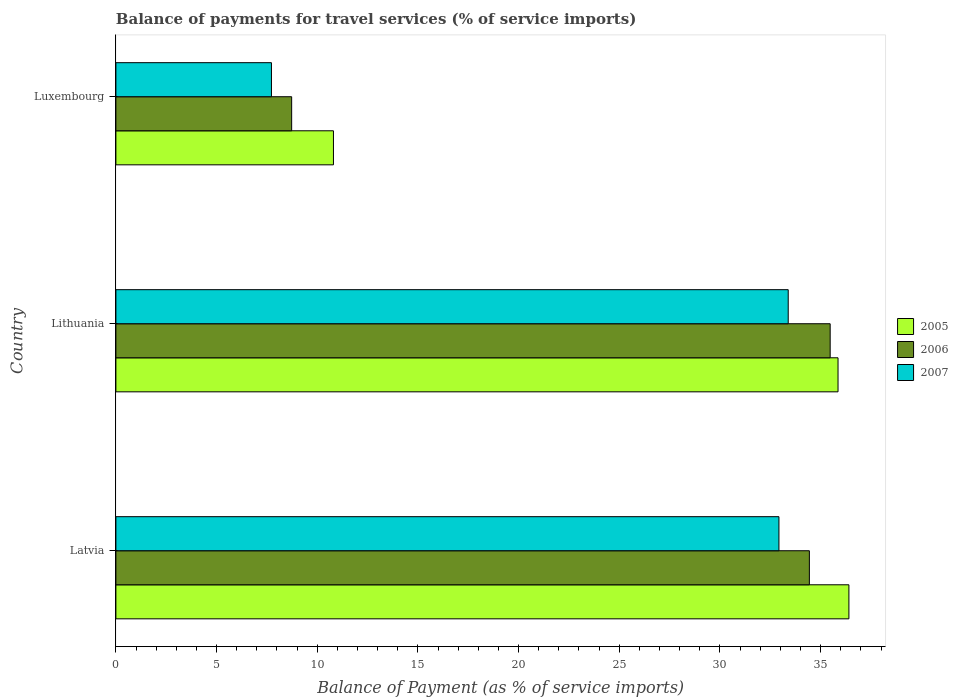Are the number of bars per tick equal to the number of legend labels?
Provide a short and direct response. Yes. Are the number of bars on each tick of the Y-axis equal?
Provide a succinct answer. Yes. How many bars are there on the 2nd tick from the bottom?
Ensure brevity in your answer.  3. What is the label of the 3rd group of bars from the top?
Provide a short and direct response. Latvia. What is the balance of payments for travel services in 2007 in Luxembourg?
Your answer should be very brief. 7.73. Across all countries, what is the maximum balance of payments for travel services in 2006?
Offer a terse response. 35.48. Across all countries, what is the minimum balance of payments for travel services in 2007?
Your answer should be compact. 7.73. In which country was the balance of payments for travel services in 2007 maximum?
Offer a terse response. Lithuania. In which country was the balance of payments for travel services in 2006 minimum?
Give a very brief answer. Luxembourg. What is the total balance of payments for travel services in 2006 in the graph?
Ensure brevity in your answer.  78.65. What is the difference between the balance of payments for travel services in 2006 in Latvia and that in Luxembourg?
Your answer should be compact. 25.71. What is the difference between the balance of payments for travel services in 2007 in Lithuania and the balance of payments for travel services in 2006 in Latvia?
Your answer should be very brief. -1.05. What is the average balance of payments for travel services in 2005 per country?
Your answer should be very brief. 27.69. What is the difference between the balance of payments for travel services in 2006 and balance of payments for travel services in 2007 in Luxembourg?
Keep it short and to the point. 1. What is the ratio of the balance of payments for travel services in 2007 in Latvia to that in Luxembourg?
Your answer should be very brief. 4.26. Is the difference between the balance of payments for travel services in 2006 in Lithuania and Luxembourg greater than the difference between the balance of payments for travel services in 2007 in Lithuania and Luxembourg?
Make the answer very short. Yes. What is the difference between the highest and the second highest balance of payments for travel services in 2007?
Your answer should be compact. 0.46. What is the difference between the highest and the lowest balance of payments for travel services in 2007?
Keep it short and to the point. 25.67. In how many countries, is the balance of payments for travel services in 2005 greater than the average balance of payments for travel services in 2005 taken over all countries?
Give a very brief answer. 2. Is the sum of the balance of payments for travel services in 2007 in Latvia and Lithuania greater than the maximum balance of payments for travel services in 2006 across all countries?
Offer a terse response. Yes. What does the 1st bar from the bottom in Luxembourg represents?
Offer a very short reply. 2005. Is it the case that in every country, the sum of the balance of payments for travel services in 2006 and balance of payments for travel services in 2007 is greater than the balance of payments for travel services in 2005?
Ensure brevity in your answer.  Yes. How many bars are there?
Offer a terse response. 9. Are the values on the major ticks of X-axis written in scientific E-notation?
Make the answer very short. No. Does the graph contain any zero values?
Provide a succinct answer. No. Where does the legend appear in the graph?
Ensure brevity in your answer.  Center right. How many legend labels are there?
Offer a terse response. 3. What is the title of the graph?
Your answer should be very brief. Balance of payments for travel services (% of service imports). What is the label or title of the X-axis?
Keep it short and to the point. Balance of Payment (as % of service imports). What is the Balance of Payment (as % of service imports) of 2005 in Latvia?
Make the answer very short. 36.41. What is the Balance of Payment (as % of service imports) in 2006 in Latvia?
Provide a short and direct response. 34.44. What is the Balance of Payment (as % of service imports) of 2007 in Latvia?
Provide a short and direct response. 32.93. What is the Balance of Payment (as % of service imports) of 2005 in Lithuania?
Ensure brevity in your answer.  35.87. What is the Balance of Payment (as % of service imports) in 2006 in Lithuania?
Give a very brief answer. 35.48. What is the Balance of Payment (as % of service imports) in 2007 in Lithuania?
Your response must be concise. 33.39. What is the Balance of Payment (as % of service imports) in 2005 in Luxembourg?
Your response must be concise. 10.81. What is the Balance of Payment (as % of service imports) in 2006 in Luxembourg?
Your answer should be compact. 8.73. What is the Balance of Payment (as % of service imports) of 2007 in Luxembourg?
Your answer should be compact. 7.73. Across all countries, what is the maximum Balance of Payment (as % of service imports) of 2005?
Provide a succinct answer. 36.41. Across all countries, what is the maximum Balance of Payment (as % of service imports) in 2006?
Offer a terse response. 35.48. Across all countries, what is the maximum Balance of Payment (as % of service imports) of 2007?
Offer a very short reply. 33.39. Across all countries, what is the minimum Balance of Payment (as % of service imports) in 2005?
Provide a succinct answer. 10.81. Across all countries, what is the minimum Balance of Payment (as % of service imports) in 2006?
Provide a short and direct response. 8.73. Across all countries, what is the minimum Balance of Payment (as % of service imports) in 2007?
Provide a succinct answer. 7.73. What is the total Balance of Payment (as % of service imports) of 2005 in the graph?
Ensure brevity in your answer.  83.08. What is the total Balance of Payment (as % of service imports) of 2006 in the graph?
Offer a very short reply. 78.65. What is the total Balance of Payment (as % of service imports) in 2007 in the graph?
Your response must be concise. 74.05. What is the difference between the Balance of Payment (as % of service imports) of 2005 in Latvia and that in Lithuania?
Your response must be concise. 0.54. What is the difference between the Balance of Payment (as % of service imports) of 2006 in Latvia and that in Lithuania?
Your response must be concise. -1.03. What is the difference between the Balance of Payment (as % of service imports) in 2007 in Latvia and that in Lithuania?
Your answer should be compact. -0.46. What is the difference between the Balance of Payment (as % of service imports) of 2005 in Latvia and that in Luxembourg?
Keep it short and to the point. 25.6. What is the difference between the Balance of Payment (as % of service imports) in 2006 in Latvia and that in Luxembourg?
Ensure brevity in your answer.  25.71. What is the difference between the Balance of Payment (as % of service imports) in 2007 in Latvia and that in Luxembourg?
Your answer should be compact. 25.21. What is the difference between the Balance of Payment (as % of service imports) of 2005 in Lithuania and that in Luxembourg?
Offer a terse response. 25.06. What is the difference between the Balance of Payment (as % of service imports) in 2006 in Lithuania and that in Luxembourg?
Your response must be concise. 26.75. What is the difference between the Balance of Payment (as % of service imports) of 2007 in Lithuania and that in Luxembourg?
Offer a terse response. 25.67. What is the difference between the Balance of Payment (as % of service imports) of 2005 in Latvia and the Balance of Payment (as % of service imports) of 2006 in Lithuania?
Your answer should be compact. 0.93. What is the difference between the Balance of Payment (as % of service imports) of 2005 in Latvia and the Balance of Payment (as % of service imports) of 2007 in Lithuania?
Ensure brevity in your answer.  3.01. What is the difference between the Balance of Payment (as % of service imports) in 2006 in Latvia and the Balance of Payment (as % of service imports) in 2007 in Lithuania?
Provide a short and direct response. 1.05. What is the difference between the Balance of Payment (as % of service imports) of 2005 in Latvia and the Balance of Payment (as % of service imports) of 2006 in Luxembourg?
Provide a short and direct response. 27.68. What is the difference between the Balance of Payment (as % of service imports) in 2005 in Latvia and the Balance of Payment (as % of service imports) in 2007 in Luxembourg?
Your response must be concise. 28.68. What is the difference between the Balance of Payment (as % of service imports) of 2006 in Latvia and the Balance of Payment (as % of service imports) of 2007 in Luxembourg?
Offer a very short reply. 26.72. What is the difference between the Balance of Payment (as % of service imports) of 2005 in Lithuania and the Balance of Payment (as % of service imports) of 2006 in Luxembourg?
Your response must be concise. 27.14. What is the difference between the Balance of Payment (as % of service imports) in 2005 in Lithuania and the Balance of Payment (as % of service imports) in 2007 in Luxembourg?
Your answer should be compact. 28.14. What is the difference between the Balance of Payment (as % of service imports) in 2006 in Lithuania and the Balance of Payment (as % of service imports) in 2007 in Luxembourg?
Your answer should be very brief. 27.75. What is the average Balance of Payment (as % of service imports) in 2005 per country?
Ensure brevity in your answer.  27.69. What is the average Balance of Payment (as % of service imports) of 2006 per country?
Offer a very short reply. 26.22. What is the average Balance of Payment (as % of service imports) of 2007 per country?
Make the answer very short. 24.68. What is the difference between the Balance of Payment (as % of service imports) in 2005 and Balance of Payment (as % of service imports) in 2006 in Latvia?
Give a very brief answer. 1.96. What is the difference between the Balance of Payment (as % of service imports) in 2005 and Balance of Payment (as % of service imports) in 2007 in Latvia?
Offer a very short reply. 3.47. What is the difference between the Balance of Payment (as % of service imports) of 2006 and Balance of Payment (as % of service imports) of 2007 in Latvia?
Provide a short and direct response. 1.51. What is the difference between the Balance of Payment (as % of service imports) of 2005 and Balance of Payment (as % of service imports) of 2006 in Lithuania?
Give a very brief answer. 0.39. What is the difference between the Balance of Payment (as % of service imports) in 2005 and Balance of Payment (as % of service imports) in 2007 in Lithuania?
Your answer should be compact. 2.47. What is the difference between the Balance of Payment (as % of service imports) in 2006 and Balance of Payment (as % of service imports) in 2007 in Lithuania?
Offer a very short reply. 2.08. What is the difference between the Balance of Payment (as % of service imports) of 2005 and Balance of Payment (as % of service imports) of 2006 in Luxembourg?
Your answer should be very brief. 2.08. What is the difference between the Balance of Payment (as % of service imports) of 2005 and Balance of Payment (as % of service imports) of 2007 in Luxembourg?
Your answer should be very brief. 3.08. What is the difference between the Balance of Payment (as % of service imports) in 2006 and Balance of Payment (as % of service imports) in 2007 in Luxembourg?
Offer a terse response. 1. What is the ratio of the Balance of Payment (as % of service imports) of 2005 in Latvia to that in Lithuania?
Offer a terse response. 1.01. What is the ratio of the Balance of Payment (as % of service imports) in 2006 in Latvia to that in Lithuania?
Ensure brevity in your answer.  0.97. What is the ratio of the Balance of Payment (as % of service imports) in 2007 in Latvia to that in Lithuania?
Offer a terse response. 0.99. What is the ratio of the Balance of Payment (as % of service imports) in 2005 in Latvia to that in Luxembourg?
Your response must be concise. 3.37. What is the ratio of the Balance of Payment (as % of service imports) in 2006 in Latvia to that in Luxembourg?
Your answer should be very brief. 3.95. What is the ratio of the Balance of Payment (as % of service imports) in 2007 in Latvia to that in Luxembourg?
Offer a terse response. 4.26. What is the ratio of the Balance of Payment (as % of service imports) in 2005 in Lithuania to that in Luxembourg?
Offer a terse response. 3.32. What is the ratio of the Balance of Payment (as % of service imports) in 2006 in Lithuania to that in Luxembourg?
Make the answer very short. 4.06. What is the ratio of the Balance of Payment (as % of service imports) of 2007 in Lithuania to that in Luxembourg?
Your answer should be very brief. 4.32. What is the difference between the highest and the second highest Balance of Payment (as % of service imports) in 2005?
Provide a succinct answer. 0.54. What is the difference between the highest and the second highest Balance of Payment (as % of service imports) of 2006?
Your answer should be compact. 1.03. What is the difference between the highest and the second highest Balance of Payment (as % of service imports) in 2007?
Ensure brevity in your answer.  0.46. What is the difference between the highest and the lowest Balance of Payment (as % of service imports) in 2005?
Your response must be concise. 25.6. What is the difference between the highest and the lowest Balance of Payment (as % of service imports) in 2006?
Ensure brevity in your answer.  26.75. What is the difference between the highest and the lowest Balance of Payment (as % of service imports) in 2007?
Keep it short and to the point. 25.67. 